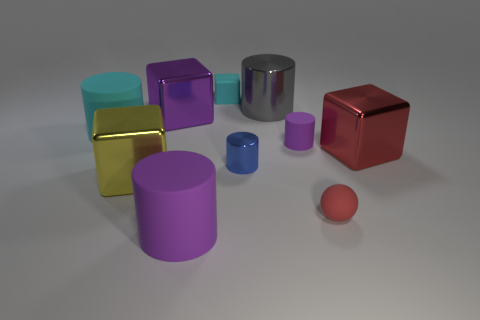Subtract all gray cylinders. How many cylinders are left? 4 Subtract all big purple matte cylinders. How many cylinders are left? 4 Subtract all gray blocks. Subtract all yellow balls. How many blocks are left? 4 Subtract all cubes. How many objects are left? 6 Subtract 0 blue balls. How many objects are left? 10 Subtract all tiny red objects. Subtract all small rubber things. How many objects are left? 6 Add 6 big cyan rubber things. How many big cyan rubber things are left? 7 Add 9 gray metallic things. How many gray metallic things exist? 10 